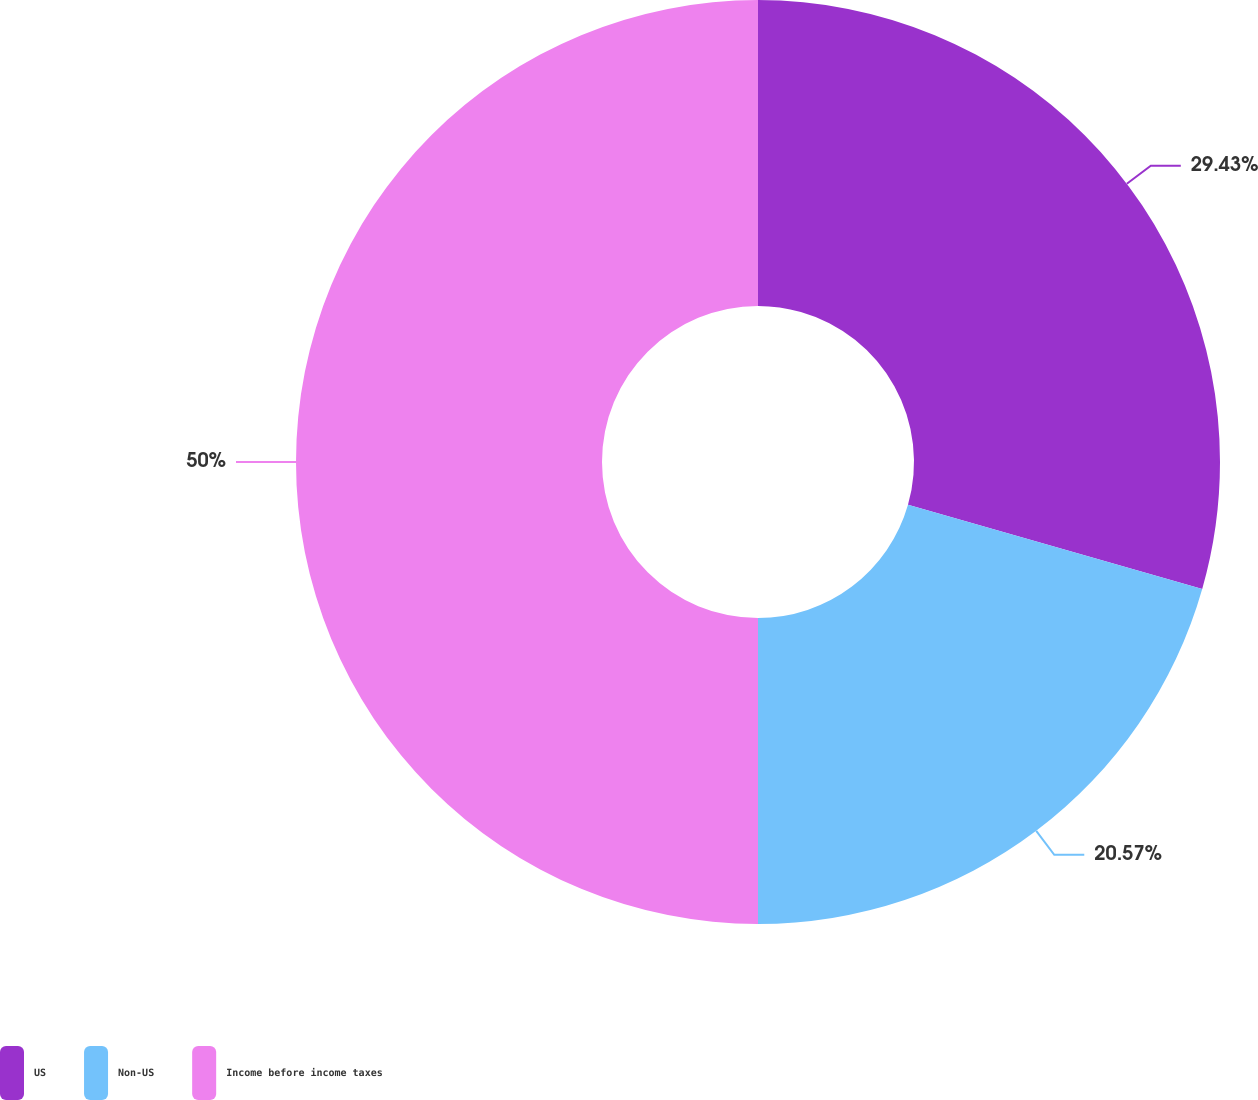Convert chart. <chart><loc_0><loc_0><loc_500><loc_500><pie_chart><fcel>US<fcel>Non-US<fcel>Income before income taxes<nl><fcel>29.43%<fcel>20.57%<fcel>50.0%<nl></chart> 